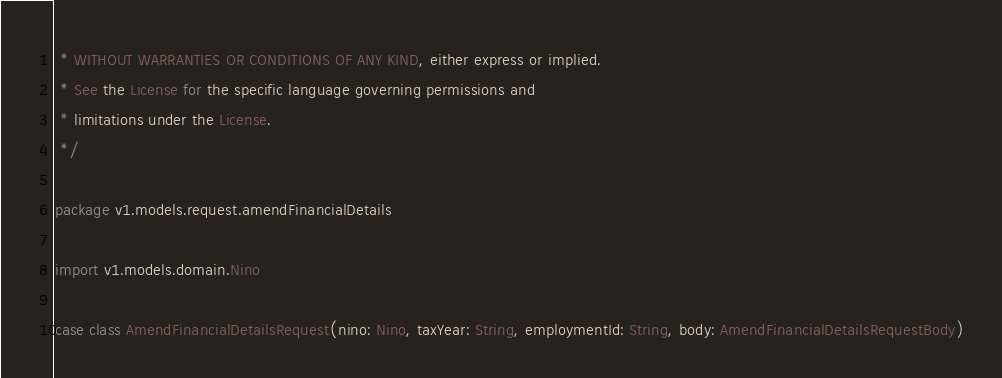<code> <loc_0><loc_0><loc_500><loc_500><_Scala_> * WITHOUT WARRANTIES OR CONDITIONS OF ANY KIND, either express or implied.
 * See the License for the specific language governing permissions and
 * limitations under the License.
 */

package v1.models.request.amendFinancialDetails

import v1.models.domain.Nino

case class AmendFinancialDetailsRequest(nino: Nino, taxYear: String, employmentId: String, body: AmendFinancialDetailsRequestBody)</code> 